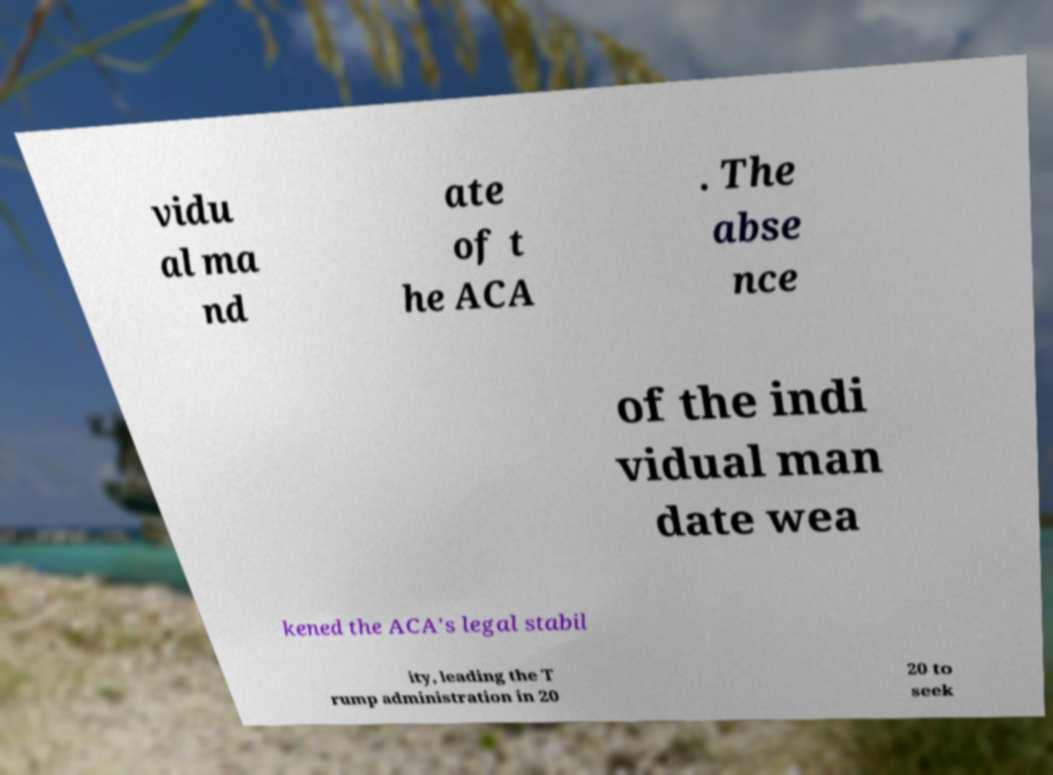Could you extract and type out the text from this image? vidu al ma nd ate of t he ACA . The abse nce of the indi vidual man date wea kened the ACA's legal stabil ity, leading the T rump administration in 20 20 to seek 